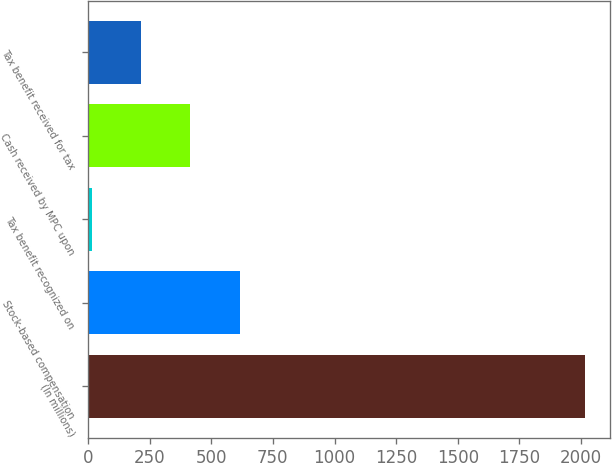<chart> <loc_0><loc_0><loc_500><loc_500><bar_chart><fcel>(In millions)<fcel>Stock-based compensation<fcel>Tax benefit recognized on<fcel>Cash received by MPC upon<fcel>Tax benefit received for tax<nl><fcel>2015<fcel>615.7<fcel>16<fcel>415.8<fcel>215.9<nl></chart> 